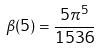<formula> <loc_0><loc_0><loc_500><loc_500>\beta ( 5 ) = \frac { 5 \pi ^ { 5 } } { 1 5 3 6 }</formula> 